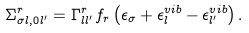Convert formula to latex. <formula><loc_0><loc_0><loc_500><loc_500>\Sigma _ { \sigma l , 0 l ^ { \prime } } ^ { r } = \Gamma _ { l l ^ { \prime } } ^ { r } f _ { r } \left ( \epsilon _ { \sigma } + \epsilon _ { l } ^ { v i b } - \epsilon _ { l ^ { \prime } } ^ { v i b } \right ) .</formula> 